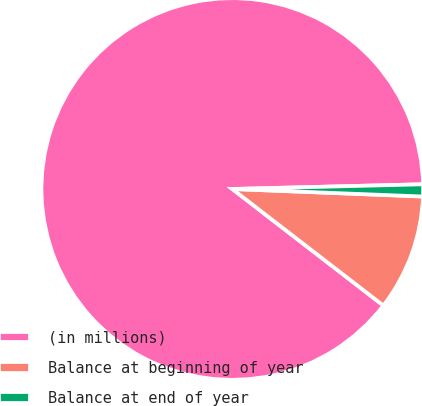<chart> <loc_0><loc_0><loc_500><loc_500><pie_chart><fcel>(in millions)<fcel>Balance at beginning of year<fcel>Balance at end of year<nl><fcel>89.15%<fcel>9.83%<fcel>1.02%<nl></chart> 